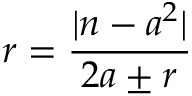<formula> <loc_0><loc_0><loc_500><loc_500>r = { \frac { | n - a ^ { 2 } | } { 2 a \pm r } }</formula> 